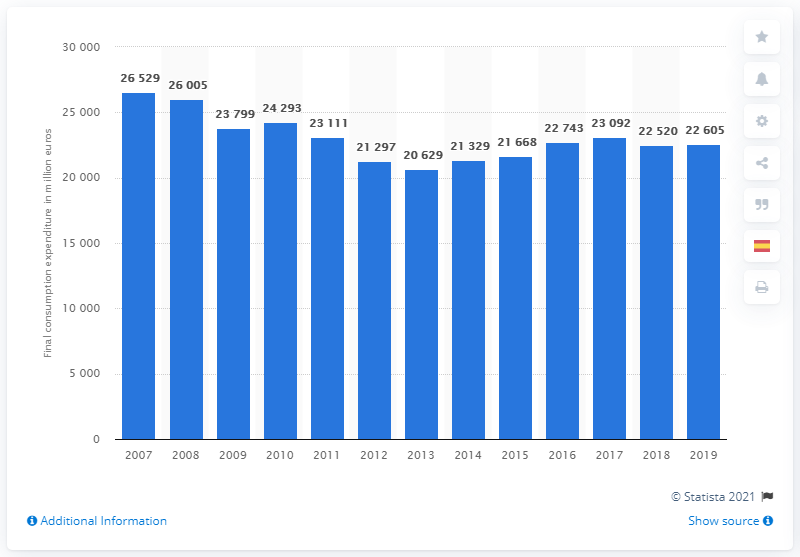Outline some significant characteristics in this image. During the period of 2007 to 2019, Spain spent an estimated 22,605 million euros on clothing. 